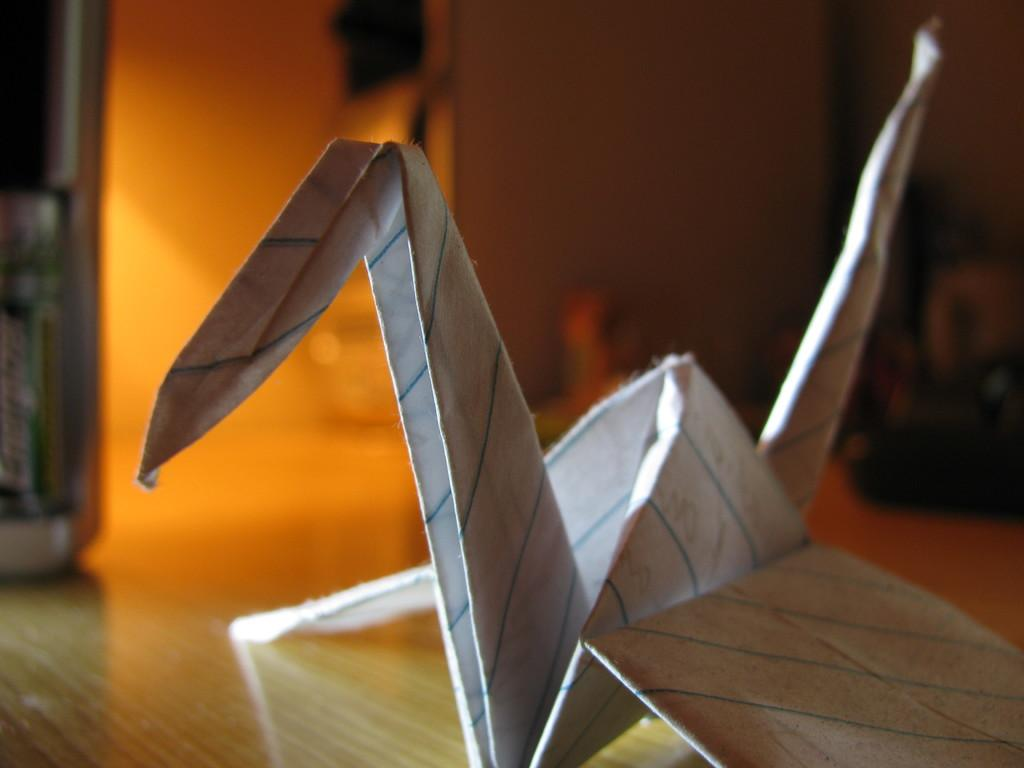What type of craft is visible in the image? There is a paper craft in the image. What surface is the paper craft placed on? The paper craft is on a wooden surface. What type of branch is holding the paper craft in the image? There is no branch present in the image; the paper craft is on a wooden surface. 